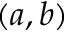Convert formula to latex. <formula><loc_0><loc_0><loc_500><loc_500>( a , b )</formula> 